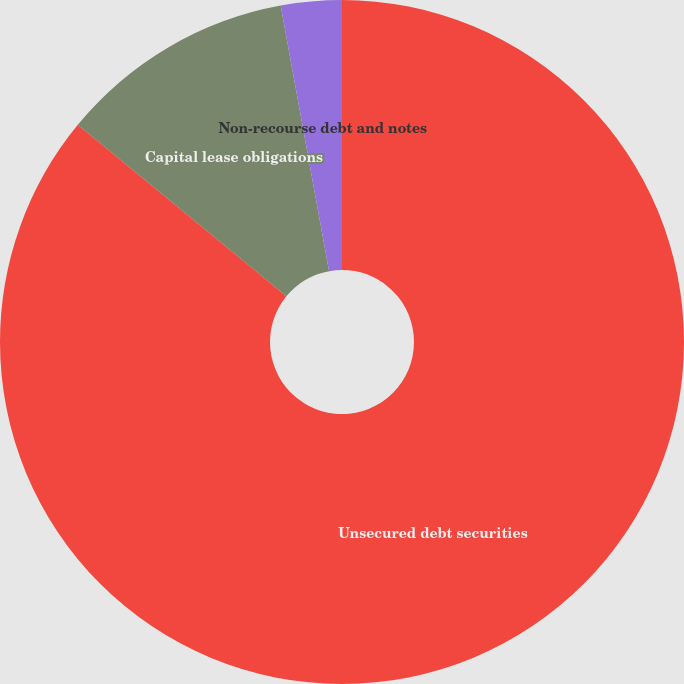<chart> <loc_0><loc_0><loc_500><loc_500><pie_chart><fcel>Unsecured debt securities<fcel>Capital lease obligations<fcel>Non-recourse debt and notes<nl><fcel>85.94%<fcel>11.18%<fcel>2.87%<nl></chart> 